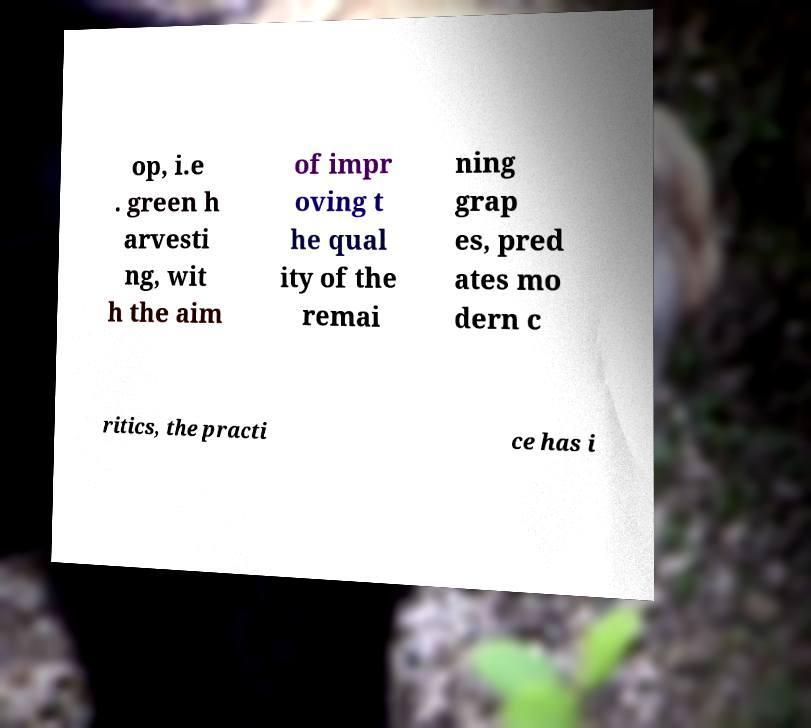Could you assist in decoding the text presented in this image and type it out clearly? op, i.e . green h arvesti ng, wit h the aim of impr oving t he qual ity of the remai ning grap es, pred ates mo dern c ritics, the practi ce has i 